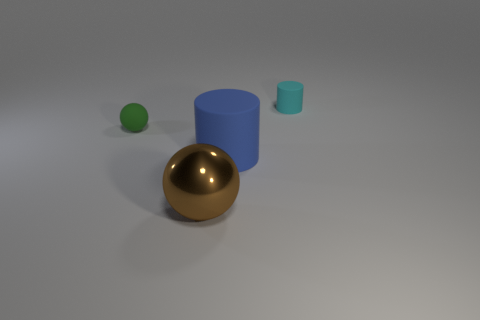There is a big blue rubber thing; is its shape the same as the tiny rubber thing on the right side of the large blue matte object?
Offer a terse response. Yes. What number of small cyan matte cylinders are to the right of the brown metallic sphere?
Give a very brief answer. 1. Is there anything else that has the same material as the big brown sphere?
Offer a terse response. No. Is the shape of the small matte object on the right side of the rubber sphere the same as  the big blue matte object?
Make the answer very short. Yes. There is a big object right of the brown thing; what color is it?
Offer a terse response. Blue. The tiny green object that is made of the same material as the blue thing is what shape?
Offer a very short reply. Sphere. Is there anything else that is the same color as the big cylinder?
Ensure brevity in your answer.  No. Is the number of large things that are to the left of the big cylinder greater than the number of brown metal spheres that are on the right side of the tiny cyan matte cylinder?
Keep it short and to the point. Yes. How many cylinders have the same size as the brown metal sphere?
Make the answer very short. 1. Is the number of large metallic balls that are right of the small cyan matte thing less than the number of objects right of the small rubber sphere?
Provide a short and direct response. Yes. 